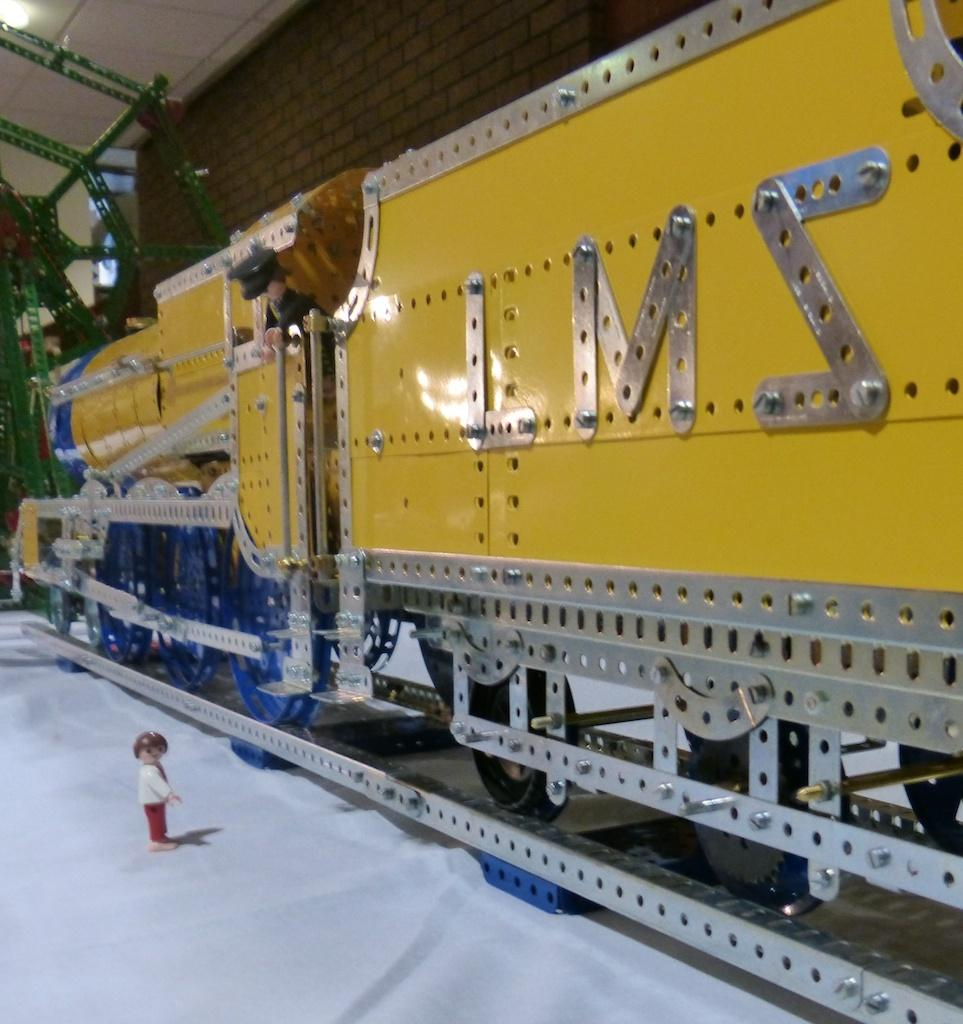<image>
Provide a brief description of the given image. A yellow train with the letters L M and a backwards Z displayed on it 